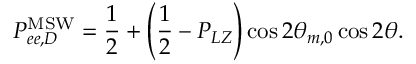Convert formula to latex. <formula><loc_0><loc_0><loc_500><loc_500>P _ { e e , D } ^ { M S W } = \frac { 1 } { 2 } + \left ( \frac { 1 } { 2 } - P _ { L Z } \right ) \cos 2 \theta _ { m , 0 } \cos 2 \theta .</formula> 